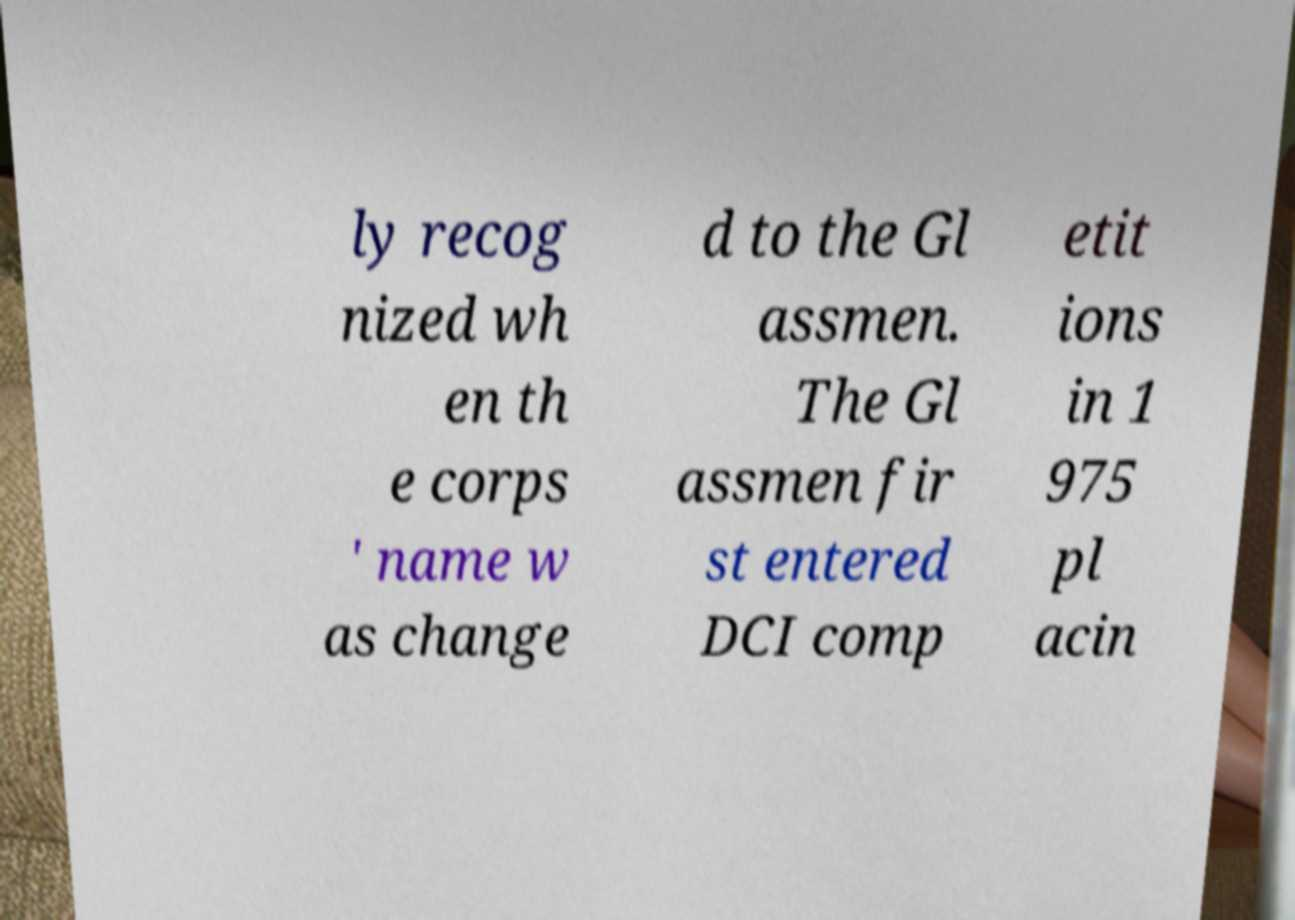Could you extract and type out the text from this image? ly recog nized wh en th e corps ' name w as change d to the Gl assmen. The Gl assmen fir st entered DCI comp etit ions in 1 975 pl acin 